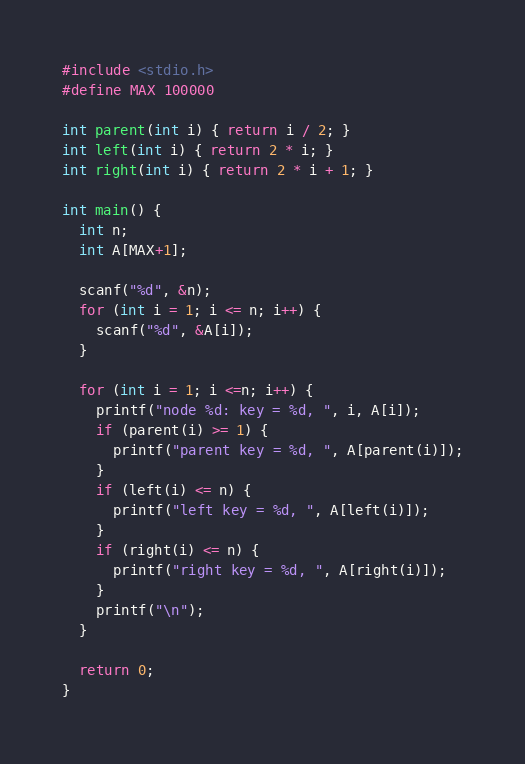<code> <loc_0><loc_0><loc_500><loc_500><_C_>#include <stdio.h>
#define MAX 100000

int parent(int i) { return i / 2; }
int left(int i) { return 2 * i; }
int right(int i) { return 2 * i + 1; }

int main() {
  int n;
  int A[MAX+1];

  scanf("%d", &n);
  for (int i = 1; i <= n; i++) {
    scanf("%d", &A[i]);
  }

  for (int i = 1; i <=n; i++) {
    printf("node %d: key = %d, ", i, A[i]);
    if (parent(i) >= 1) {
      printf("parent key = %d, ", A[parent(i)]);
    }
    if (left(i) <= n) {
      printf("left key = %d, ", A[left(i)]);
    }
    if (right(i) <= n) {
      printf("right key = %d, ", A[right(i)]);
    }
    printf("\n");
  }

  return 0;
}

</code> 